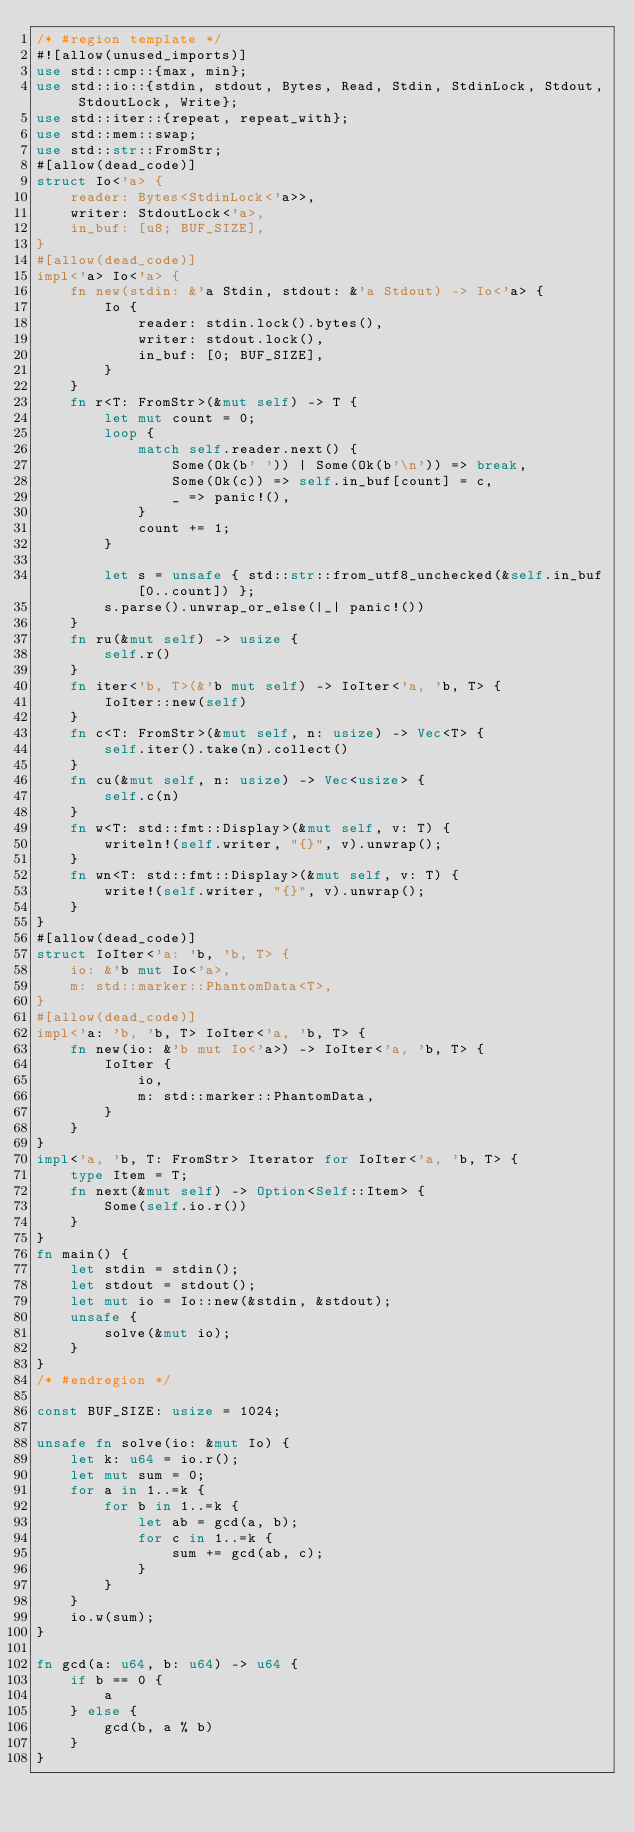<code> <loc_0><loc_0><loc_500><loc_500><_Rust_>/* #region template */
#![allow(unused_imports)]
use std::cmp::{max, min};
use std::io::{stdin, stdout, Bytes, Read, Stdin, StdinLock, Stdout, StdoutLock, Write};
use std::iter::{repeat, repeat_with};
use std::mem::swap;
use std::str::FromStr;
#[allow(dead_code)]
struct Io<'a> {
    reader: Bytes<StdinLock<'a>>,
    writer: StdoutLock<'a>,
    in_buf: [u8; BUF_SIZE],
}
#[allow(dead_code)]
impl<'a> Io<'a> {
    fn new(stdin: &'a Stdin, stdout: &'a Stdout) -> Io<'a> {
        Io {
            reader: stdin.lock().bytes(),
            writer: stdout.lock(),
            in_buf: [0; BUF_SIZE],
        }
    }
    fn r<T: FromStr>(&mut self) -> T {
        let mut count = 0;
        loop {
            match self.reader.next() {
                Some(Ok(b' ')) | Some(Ok(b'\n')) => break,
                Some(Ok(c)) => self.in_buf[count] = c,
                _ => panic!(),
            }
            count += 1;
        }

        let s = unsafe { std::str::from_utf8_unchecked(&self.in_buf[0..count]) };
        s.parse().unwrap_or_else(|_| panic!())
    }
    fn ru(&mut self) -> usize {
        self.r()
    }
    fn iter<'b, T>(&'b mut self) -> IoIter<'a, 'b, T> {
        IoIter::new(self)
    }
    fn c<T: FromStr>(&mut self, n: usize) -> Vec<T> {
        self.iter().take(n).collect()
    }
    fn cu(&mut self, n: usize) -> Vec<usize> {
        self.c(n)
    }
    fn w<T: std::fmt::Display>(&mut self, v: T) {
        writeln!(self.writer, "{}", v).unwrap();
    }
    fn wn<T: std::fmt::Display>(&mut self, v: T) {
        write!(self.writer, "{}", v).unwrap();
    }
}
#[allow(dead_code)]
struct IoIter<'a: 'b, 'b, T> {
    io: &'b mut Io<'a>,
    m: std::marker::PhantomData<T>,
}
#[allow(dead_code)]
impl<'a: 'b, 'b, T> IoIter<'a, 'b, T> {
    fn new(io: &'b mut Io<'a>) -> IoIter<'a, 'b, T> {
        IoIter {
            io,
            m: std::marker::PhantomData,
        }
    }
}
impl<'a, 'b, T: FromStr> Iterator for IoIter<'a, 'b, T> {
    type Item = T;
    fn next(&mut self) -> Option<Self::Item> {
        Some(self.io.r())
    }
}
fn main() {
    let stdin = stdin();
    let stdout = stdout();
    let mut io = Io::new(&stdin, &stdout);
    unsafe {
        solve(&mut io);
    }
}
/* #endregion */

const BUF_SIZE: usize = 1024;

unsafe fn solve(io: &mut Io) {
    let k: u64 = io.r();
    let mut sum = 0;
    for a in 1..=k {
        for b in 1..=k {
            let ab = gcd(a, b);
            for c in 1..=k {
                sum += gcd(ab, c);
            }
        }
    }
    io.w(sum);
}

fn gcd(a: u64, b: u64) -> u64 {
    if b == 0 {
        a
    } else {
        gcd(b, a % b)
    }
}
</code> 